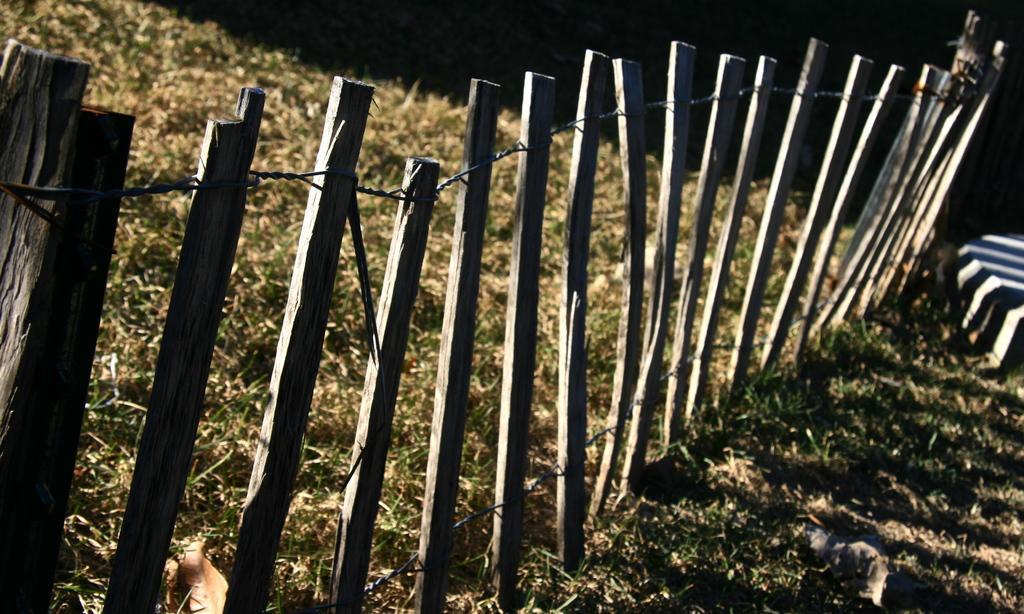In one or two sentences, can you explain what this image depicts? In this picture I can see fence and grass on the ground and I can see dark background. 